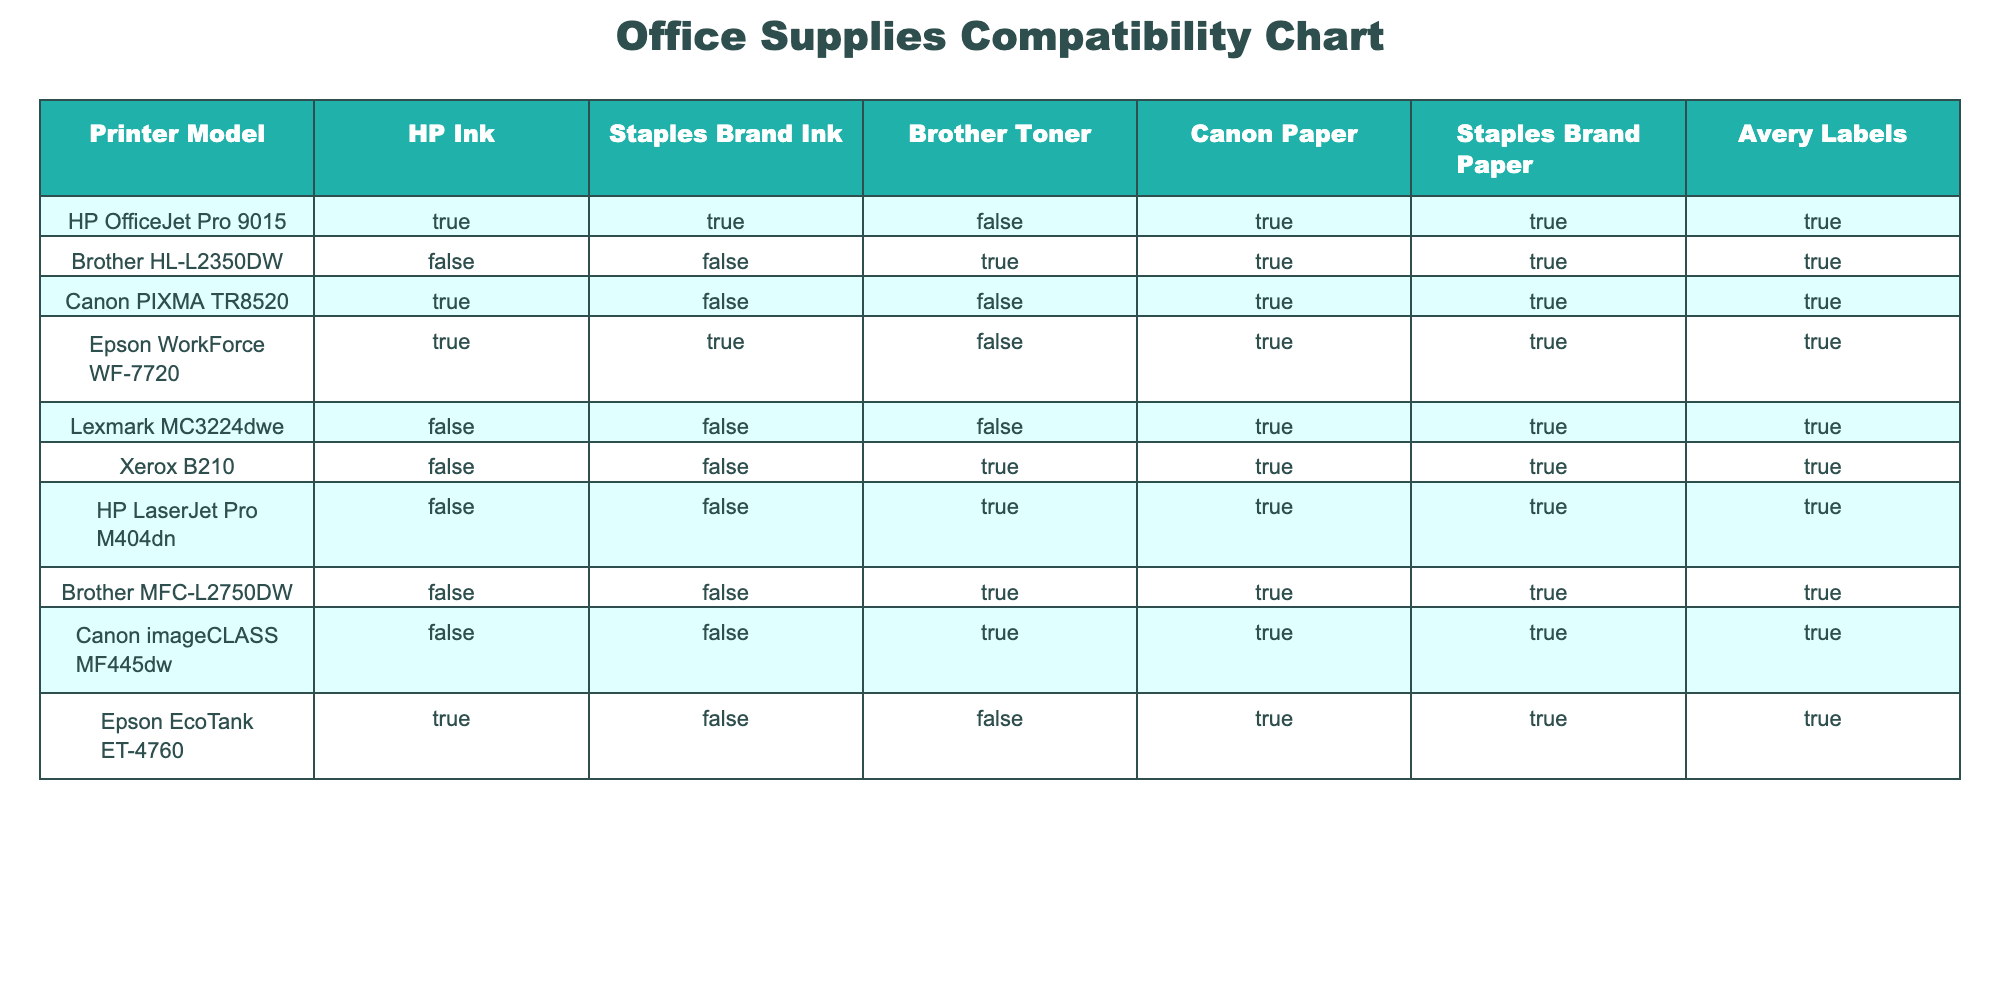What types of ink are compatible with the Canon PIXMA TR8520? To find the compatible inks for the Canon PIXMA TR8520, I look at the row corresponding to this printer model. The table indicates "True" for HP Ink and "False" for Staples Brand Ink. Thus, only HP Ink is compatible with this model.
Answer: HP Ink Is Staples Brand Paper compatible with the Epson EcoTank ET-4760? I check the row for the Epson EcoTank ET-4760, where it's listed under the column for Staples Brand Paper. The table shows "True," indicating compatibility.
Answer: Yes Which printer models do not support Staples Brand Ink? I review all rows to identify models marked as "False" under Staples Brand Ink. The Brother HL-L2350DW, Canon PIXMA TR8520, Lexmark MC3224dwe, HP LaserJet Pro M404dn, Brother MFC-L2750DW, and Canon imageCLASS MF445dw do not support Staples Brand Ink.
Answer: 6 models: Brother HL-L2350DW, Canon PIXMA TR8520, Lexmark MC3224dwe, HP LaserJet Pro M404dn, Brother MFC-L2750DW, Canon imageCLASS MF445dw How many printer models support Canon Paper? I go through the entire column for Canon Paper to count the models marked "True." The compatible models are HP OfficeJet Pro 9015, Brother HL-L2350DW, Canon PIXMA TR8520, Epson WorkForce WF-7720, Epson EcoTank ET-4760. Therefore, there are five models in total.
Answer: 5 models Does the Brother HL-L2350DW support Avery Labels? To answer this, I look at the row for Brother HL-L2350DW and check the column for Avery Labels. The table shows "True," indicating that it does support Avery Labels.
Answer: Yes Which printer has the maximum number of compatible supplies? I compare all rows to tally the number of "True" values across all supply categories. The HP OfficeJet Pro 9015 supports 6 supplies (all marked "True"), while others have fewer. Therefore, it has the maximum compatibility.
Answer: HP OfficeJet Pro 9015 